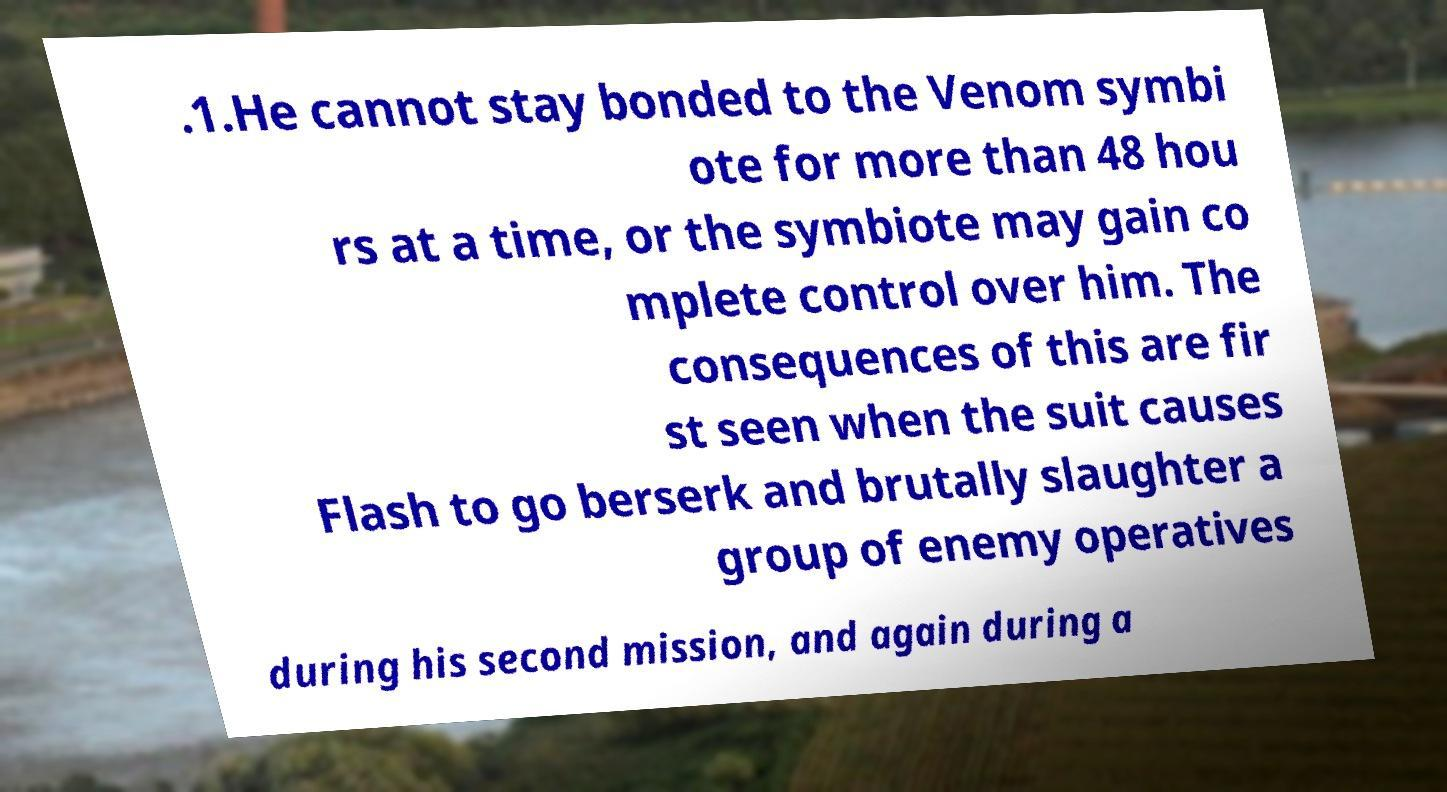Please identify and transcribe the text found in this image. .1.He cannot stay bonded to the Venom symbi ote for more than 48 hou rs at a time, or the symbiote may gain co mplete control over him. The consequences of this are fir st seen when the suit causes Flash to go berserk and brutally slaughter a group of enemy operatives during his second mission, and again during a 